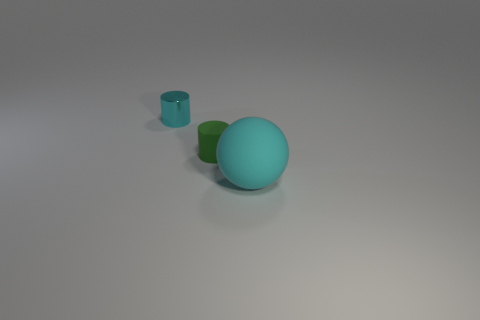Are the cyan sphere and the green cylinder made of the same material?
Provide a succinct answer. Yes. What number of other things are the same shape as the large cyan thing?
Offer a terse response. 0. There is a object that is behind the ball and in front of the cyan cylinder; what is its size?
Offer a terse response. Small. What number of metal objects are either tiny green cylinders or tiny red objects?
Provide a succinct answer. 0. Do the small thing that is in front of the tiny cyan metallic cylinder and the tiny object that is left of the green rubber cylinder have the same shape?
Provide a succinct answer. Yes. Is there a big cyan ball that has the same material as the tiny cyan object?
Keep it short and to the point. No. The rubber ball has what color?
Offer a very short reply. Cyan. What is the size of the cylinder right of the cyan metallic cylinder?
Offer a terse response. Small. How many things are the same color as the small metallic cylinder?
Provide a succinct answer. 1. There is a cyan object behind the big cyan sphere; are there any tiny cyan objects that are in front of it?
Your answer should be very brief. No. 